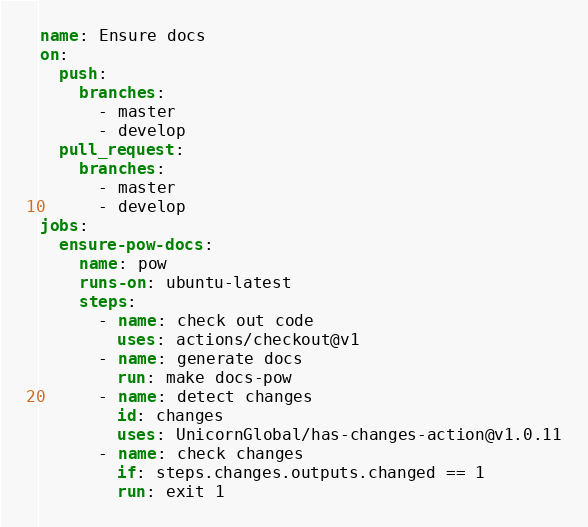Convert code to text. <code><loc_0><loc_0><loc_500><loc_500><_YAML_>name: Ensure docs
on:
  push:
    branches:
      - master
      - develop
  pull_request:
    branches:
      - master
      - develop
jobs:
  ensure-pow-docs:
    name: pow
    runs-on: ubuntu-latest
    steps:
      - name: check out code
        uses: actions/checkout@v1
      - name: generate docs
        run: make docs-pow
      - name: detect changes
        id: changes
        uses: UnicornGlobal/has-changes-action@v1.0.11
      - name: check changes
        if: steps.changes.outputs.changed == 1
        run: exit 1
</code> 